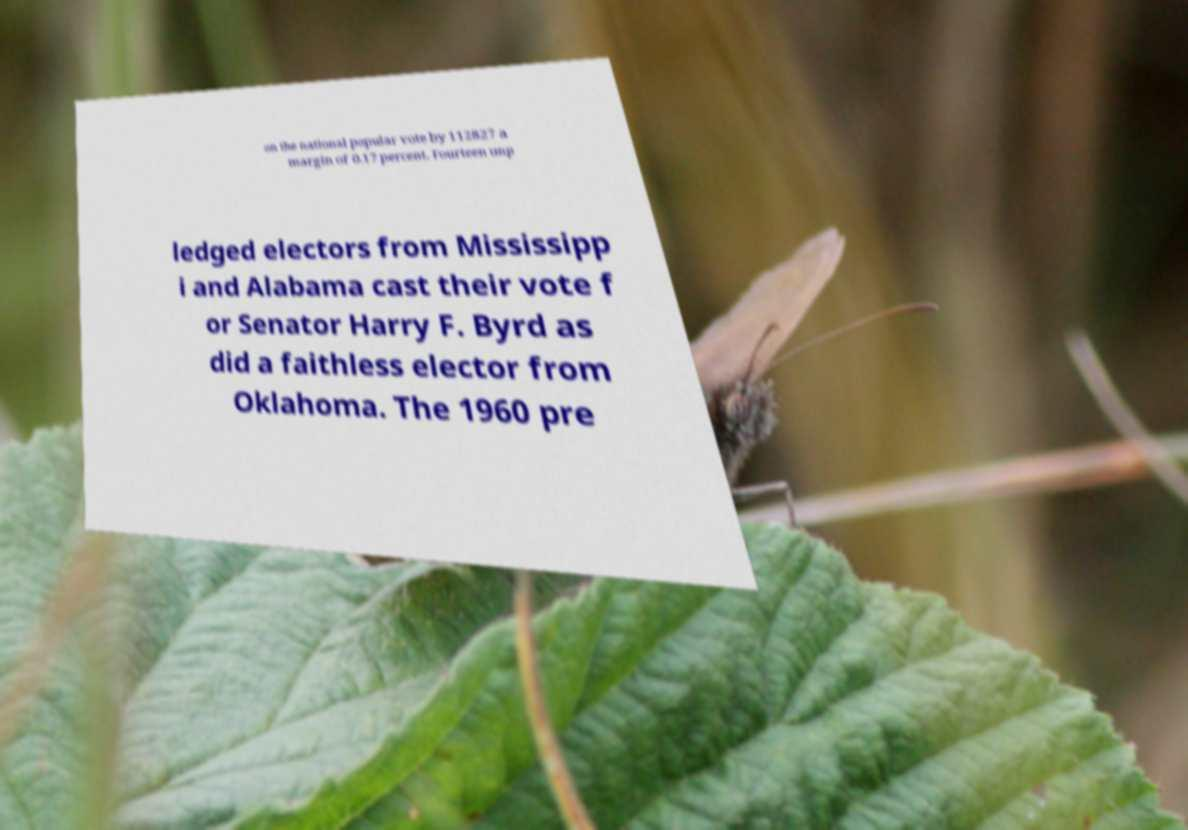Could you extract and type out the text from this image? on the national popular vote by 112827 a margin of 0.17 percent. Fourteen unp ledged electors from Mississipp i and Alabama cast their vote f or Senator Harry F. Byrd as did a faithless elector from Oklahoma. The 1960 pre 